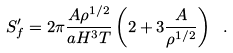Convert formula to latex. <formula><loc_0><loc_0><loc_500><loc_500>S _ { f } ^ { \prime } = 2 \pi \frac { A \rho ^ { 1 / 2 } } { a H ^ { 3 } T } \left ( 2 + 3 \frac { A } { \rho ^ { 1 / 2 } } \right ) \ .</formula> 